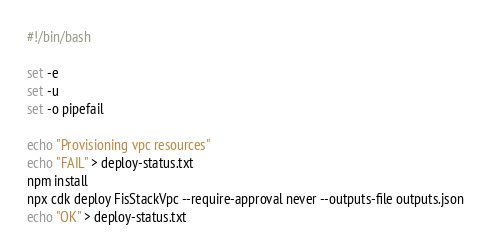Convert code to text. <code><loc_0><loc_0><loc_500><loc_500><_Bash_>#!/bin/bash

set -e
set -u
set -o pipefail

echo "Provisioning vpc resources"
echo "FAIL" > deploy-status.txt
npm install
npx cdk deploy FisStackVpc --require-approval never --outputs-file outputs.json
echo "OK" > deploy-status.txt

</code> 